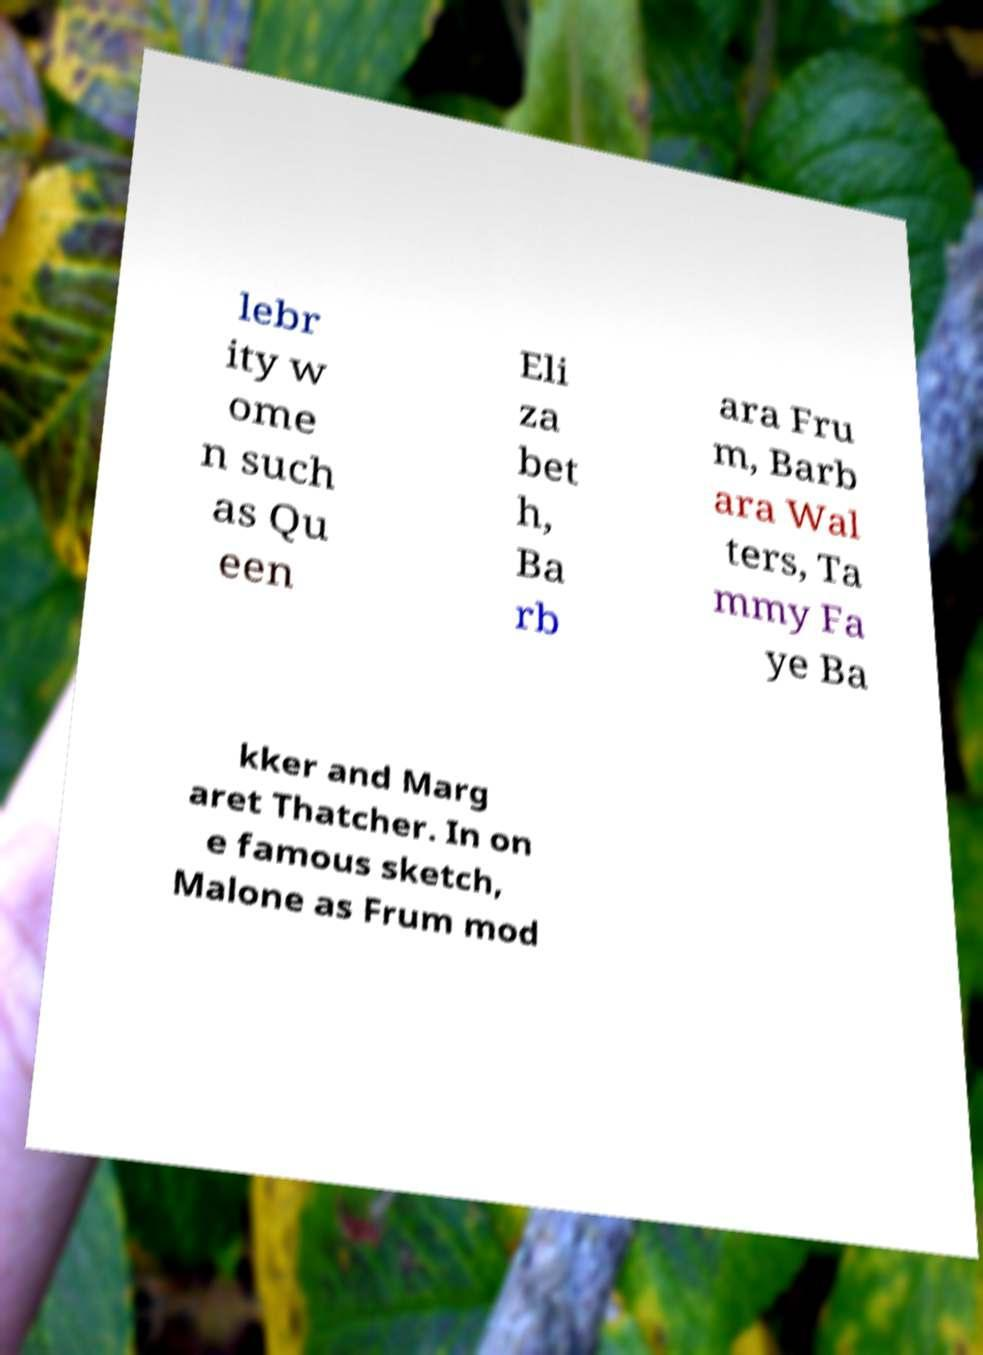What messages or text are displayed in this image? I need them in a readable, typed format. lebr ity w ome n such as Qu een Eli za bet h, Ba rb ara Fru m, Barb ara Wal ters, Ta mmy Fa ye Ba kker and Marg aret Thatcher. In on e famous sketch, Malone as Frum mod 